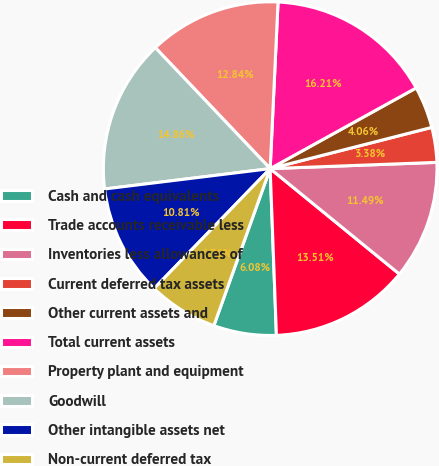Convert chart to OTSL. <chart><loc_0><loc_0><loc_500><loc_500><pie_chart><fcel>Cash and cash equivalents<fcel>Trade accounts receivable less<fcel>Inventories less allowances of<fcel>Current deferred tax assets<fcel>Other current assets and<fcel>Total current assets<fcel>Property plant and equipment<fcel>Goodwill<fcel>Other intangible assets net<fcel>Non-current deferred tax<nl><fcel>6.08%<fcel>13.51%<fcel>11.49%<fcel>3.38%<fcel>4.06%<fcel>16.21%<fcel>12.84%<fcel>14.86%<fcel>10.81%<fcel>6.76%<nl></chart> 